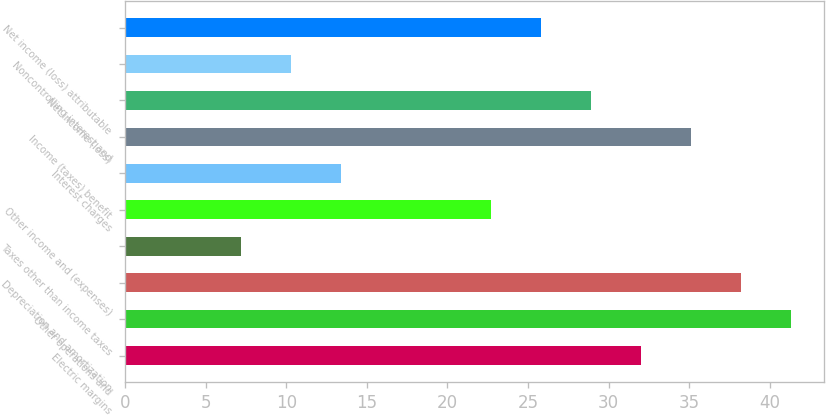Convert chart to OTSL. <chart><loc_0><loc_0><loc_500><loc_500><bar_chart><fcel>Electric margins<fcel>Other operations and<fcel>Depreciation and amortization<fcel>Taxes other than income taxes<fcel>Other income and (expenses)<fcel>Interest charges<fcel>Income (taxes) benefit<fcel>Net income (loss)<fcel>Noncontrolling interest and<fcel>Net income (loss) attributable<nl><fcel>32<fcel>41.3<fcel>38.2<fcel>7.2<fcel>22.7<fcel>13.4<fcel>35.1<fcel>28.9<fcel>10.3<fcel>25.8<nl></chart> 